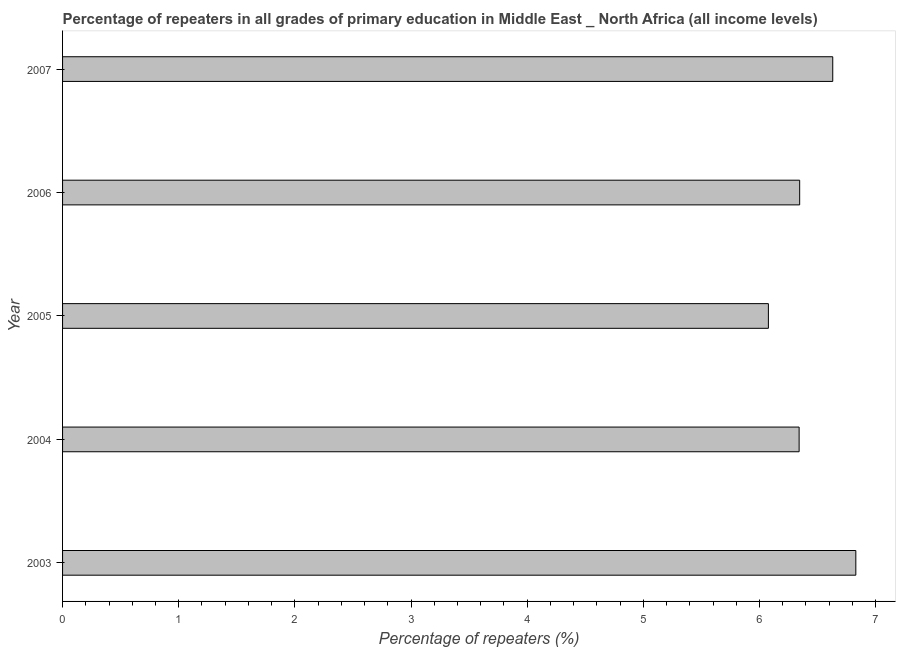Does the graph contain any zero values?
Offer a terse response. No. Does the graph contain grids?
Your answer should be very brief. No. What is the title of the graph?
Provide a succinct answer. Percentage of repeaters in all grades of primary education in Middle East _ North Africa (all income levels). What is the label or title of the X-axis?
Provide a short and direct response. Percentage of repeaters (%). What is the percentage of repeaters in primary education in 2006?
Offer a very short reply. 6.35. Across all years, what is the maximum percentage of repeaters in primary education?
Your answer should be very brief. 6.83. Across all years, what is the minimum percentage of repeaters in primary education?
Make the answer very short. 6.08. What is the sum of the percentage of repeaters in primary education?
Offer a very short reply. 32.22. What is the difference between the percentage of repeaters in primary education in 2005 and 2007?
Offer a very short reply. -0.55. What is the average percentage of repeaters in primary education per year?
Offer a terse response. 6.45. What is the median percentage of repeaters in primary education?
Your answer should be very brief. 6.35. In how many years, is the percentage of repeaters in primary education greater than 3.8 %?
Your answer should be compact. 5. Do a majority of the years between 2003 and 2006 (inclusive) have percentage of repeaters in primary education greater than 3.2 %?
Your response must be concise. Yes. What is the ratio of the percentage of repeaters in primary education in 2003 to that in 2007?
Your answer should be very brief. 1.03. Is the percentage of repeaters in primary education in 2005 less than that in 2007?
Your answer should be compact. Yes. What is the difference between the highest and the second highest percentage of repeaters in primary education?
Provide a short and direct response. 0.2. How many bars are there?
Provide a succinct answer. 5. Are all the bars in the graph horizontal?
Ensure brevity in your answer.  Yes. Are the values on the major ticks of X-axis written in scientific E-notation?
Your answer should be very brief. No. What is the Percentage of repeaters (%) of 2003?
Offer a very short reply. 6.83. What is the Percentage of repeaters (%) in 2004?
Your answer should be compact. 6.34. What is the Percentage of repeaters (%) of 2005?
Ensure brevity in your answer.  6.08. What is the Percentage of repeaters (%) in 2006?
Provide a succinct answer. 6.35. What is the Percentage of repeaters (%) of 2007?
Make the answer very short. 6.63. What is the difference between the Percentage of repeaters (%) in 2003 and 2004?
Provide a succinct answer. 0.49. What is the difference between the Percentage of repeaters (%) in 2003 and 2005?
Give a very brief answer. 0.75. What is the difference between the Percentage of repeaters (%) in 2003 and 2006?
Provide a short and direct response. 0.48. What is the difference between the Percentage of repeaters (%) in 2003 and 2007?
Give a very brief answer. 0.2. What is the difference between the Percentage of repeaters (%) in 2004 and 2005?
Make the answer very short. 0.26. What is the difference between the Percentage of repeaters (%) in 2004 and 2006?
Your answer should be very brief. -0. What is the difference between the Percentage of repeaters (%) in 2004 and 2007?
Your answer should be very brief. -0.29. What is the difference between the Percentage of repeaters (%) in 2005 and 2006?
Your answer should be compact. -0.27. What is the difference between the Percentage of repeaters (%) in 2005 and 2007?
Provide a short and direct response. -0.55. What is the difference between the Percentage of repeaters (%) in 2006 and 2007?
Ensure brevity in your answer.  -0.28. What is the ratio of the Percentage of repeaters (%) in 2003 to that in 2004?
Provide a short and direct response. 1.08. What is the ratio of the Percentage of repeaters (%) in 2003 to that in 2005?
Make the answer very short. 1.12. What is the ratio of the Percentage of repeaters (%) in 2003 to that in 2006?
Make the answer very short. 1.08. What is the ratio of the Percentage of repeaters (%) in 2004 to that in 2005?
Your answer should be compact. 1.04. What is the ratio of the Percentage of repeaters (%) in 2004 to that in 2007?
Your response must be concise. 0.96. What is the ratio of the Percentage of repeaters (%) in 2005 to that in 2006?
Provide a short and direct response. 0.96. What is the ratio of the Percentage of repeaters (%) in 2005 to that in 2007?
Provide a short and direct response. 0.92. 